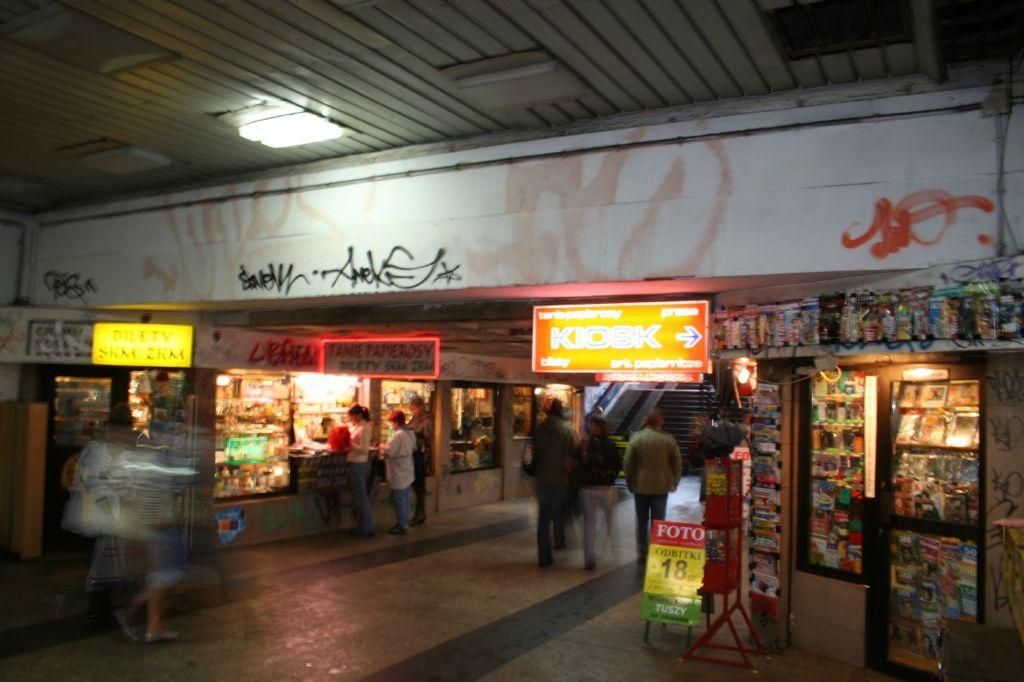<image>
Render a clear and concise summary of the photo. A dark shopping area with a lighted sign that says kiosk. 